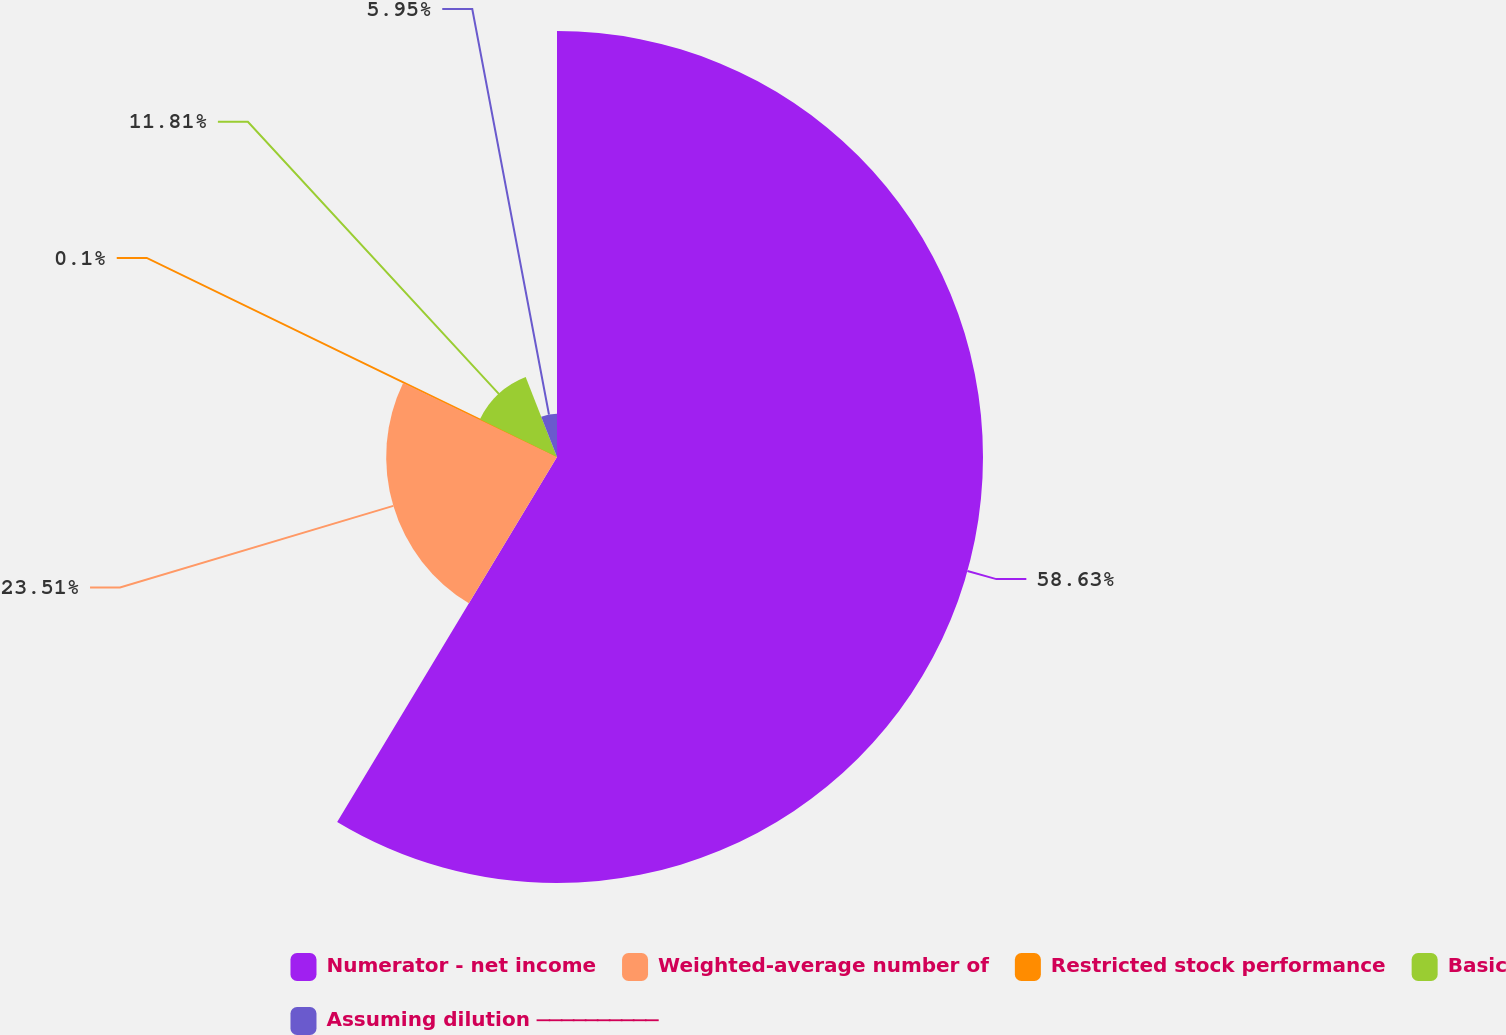<chart> <loc_0><loc_0><loc_500><loc_500><pie_chart><fcel>Numerator - net income<fcel>Weighted-average number of<fcel>Restricted stock performance<fcel>Basic<fcel>Assuming dilution ⎯⎯⎯⎯⎯⎯⎯⎯⎯⎯<nl><fcel>58.63%<fcel>23.51%<fcel>0.1%<fcel>11.81%<fcel>5.95%<nl></chart> 